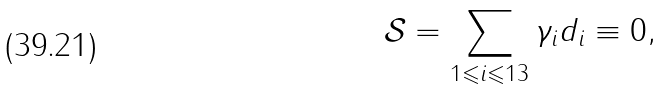Convert formula to latex. <formula><loc_0><loc_0><loc_500><loc_500>\mathcal { S } = \sum _ { 1 \leqslant i \leqslant 1 3 } \gamma _ { i } d _ { i } \equiv 0 ,</formula> 